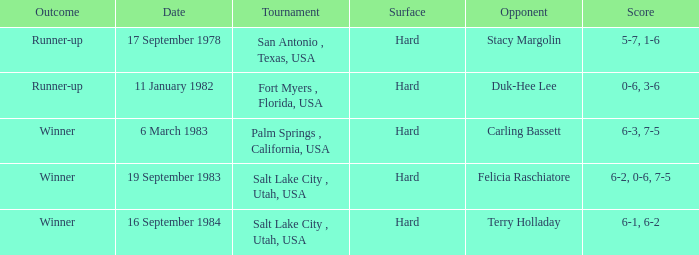What was the tally of the competition against duk-hee lee? 0-6, 3-6. 